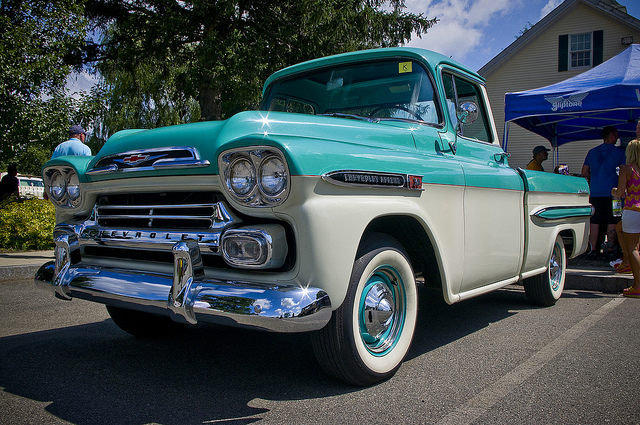Can you describe a long and detailed use case scenario for this classic truck today? Imagine a bustling town square on a warm summer afternoon. In the center, there's a vintage-themed event celebrating the golden era of the 1950s. Music from that era plays softly in the background as people dressed in retro attire mingle and reminisce. Among the attractions is this classic Chevrolet truck, which has been meticulously restored to its original glory. The truck is parked prominently, with its bed converted into a platform for a small stage. Local musicians take turns performing rock and roll hits from the 50s, attracting a crowd that sways and dances to the rhythm. The truck's polished chrome and vibrant two-tone paint gleam under the sunlight, drawing admiration and nostalgia from onlookers. Kids are fascinated by the truck, and some elderly folks share stories of their youth, recalling memories of similar vehicles they once owned or dreamed of owning. The truck not only serves as a centerpiece for the event but also as a tangible link to the past, evoking a sense of community and shared history. 